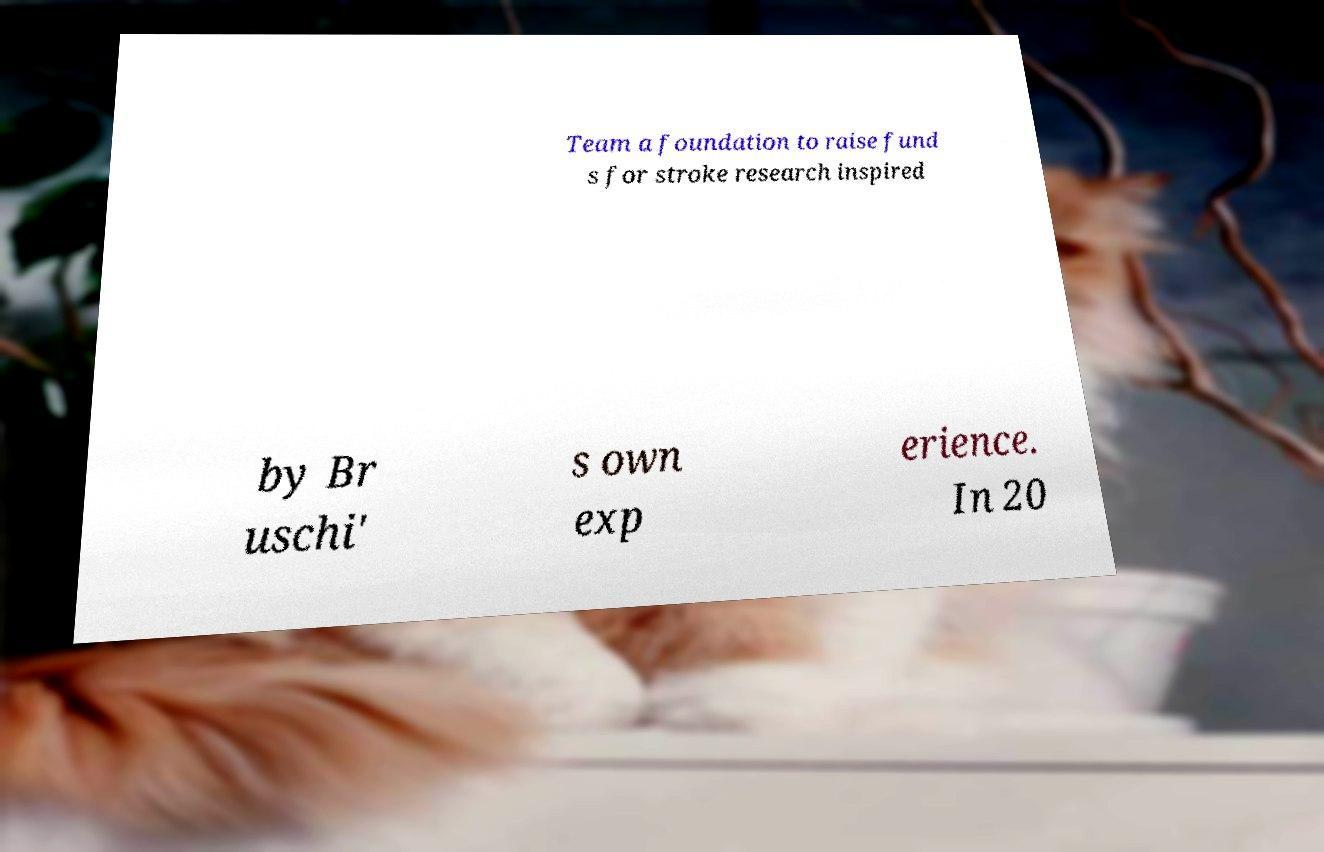Please read and relay the text visible in this image. What does it say? Team a foundation to raise fund s for stroke research inspired by Br uschi' s own exp erience. In 20 